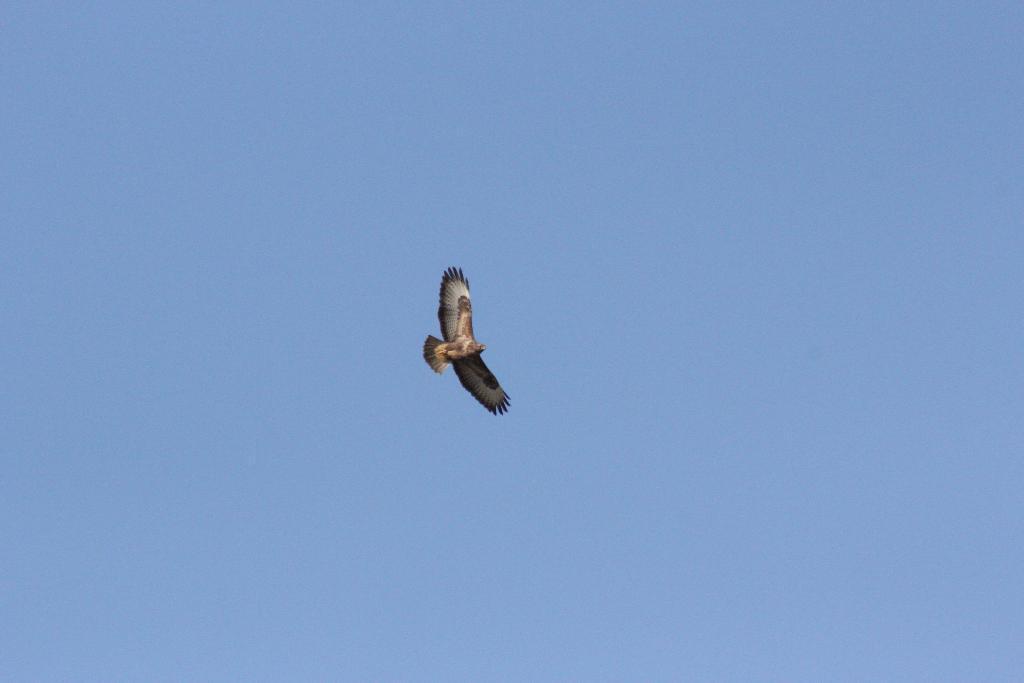Could you give a brief overview of what you see in this image? In this picture I see a bird in the center, which is of black, white and brown in color and in the background I see the clear sky. 